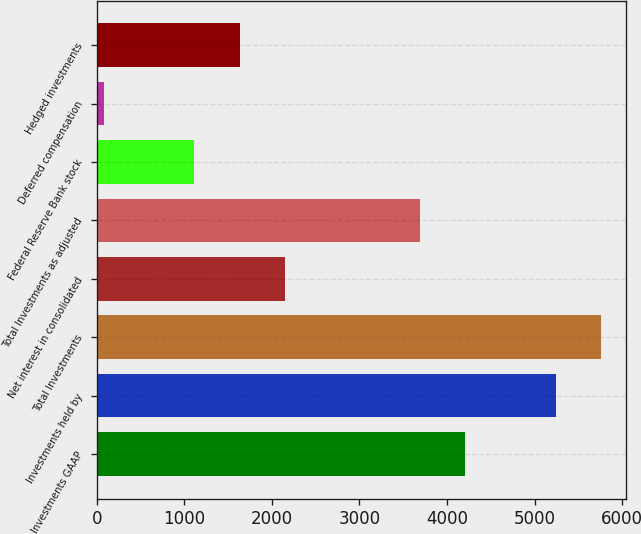<chart> <loc_0><loc_0><loc_500><loc_500><bar_chart><fcel>Investments GAAP<fcel>Investments held by<fcel>Total Investments<fcel>Net interest in consolidated<fcel>Total Investments as adjusted<fcel>Federal Reserve Bank stock<fcel>Deferred compensation<fcel>Hedged investments<nl><fcel>4209.8<fcel>5241<fcel>5756.6<fcel>2147.4<fcel>3694.2<fcel>1116.2<fcel>85<fcel>1631.8<nl></chart> 